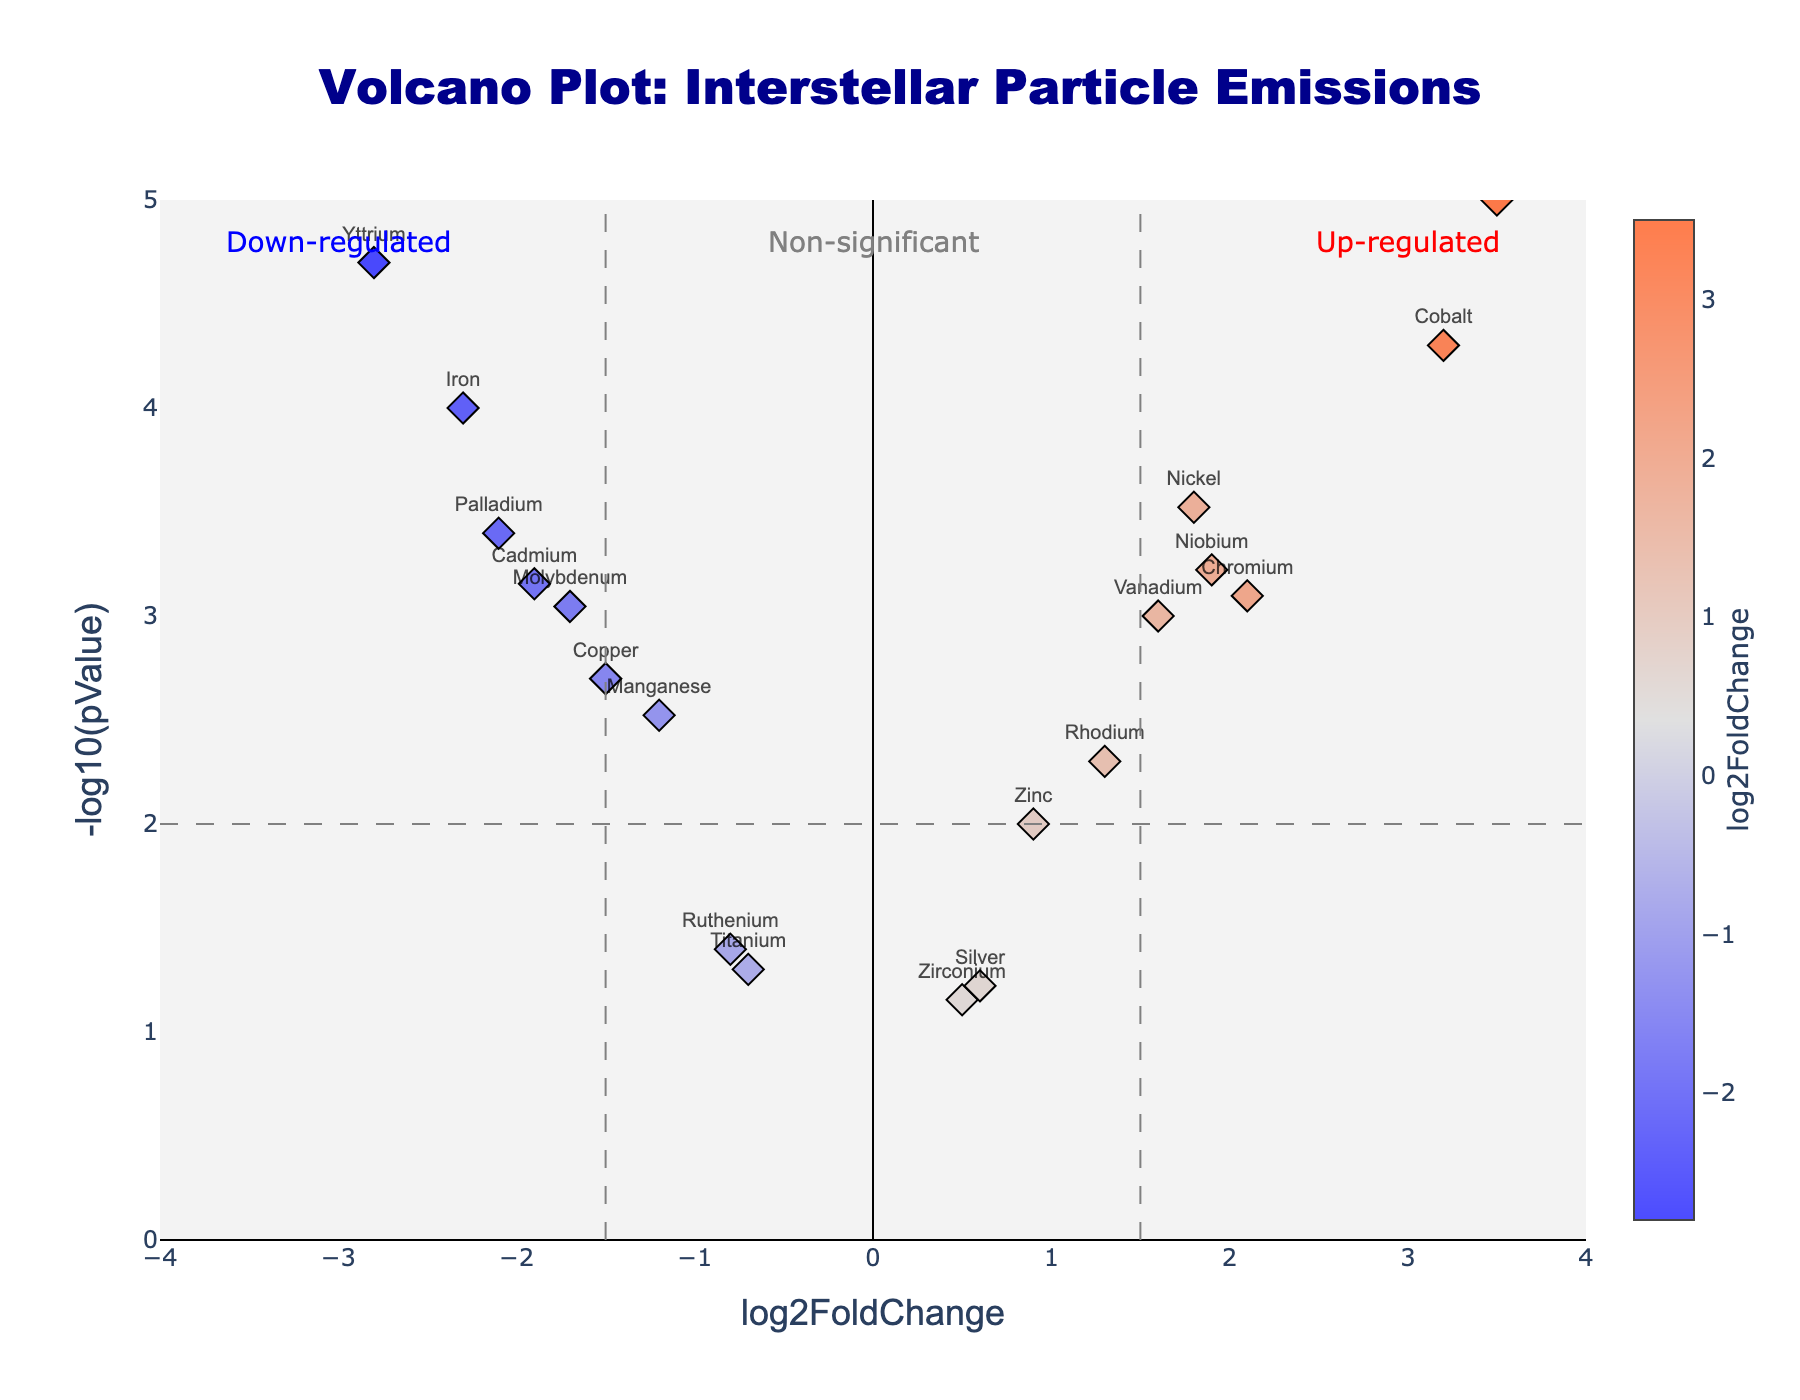Which element shows the highest up-regulation? By examining the y-axis for -log10(pValue) and looking at the highest positive log2FoldChange value, we see Technetium has the highest value.
Answer: Technetium Which element shows the highest down-regulation? By examining the y-axis for -log10(pValue) and looking at the highest negative log2FoldChange value, we see Yttrium has the highest value.
Answer: Yttrium How many elements are significantly up-regulated based on the thresholds? Elements with log2FoldChange > 1.5 and -log10(pValue) > 2 (-log10(pValue) of p < 0.01). We find Nickel, Cobalt, Chromium, Vanadium, Niobium, and Technetium meeting these criteria.
Answer: 6 How many elements are significantly down-regulated based on the thresholds? Elements with log2FoldChange < -1.5 and -log10(pValue) > 2 (-log10(pValue) of p < 0.01). We find Iron, Yttrium, Palladium, and Cadmium meeting these criteria.
Answer: 4 What is the log2FoldChange range? The log2FoldChange axis ranges from approximately -4 to 4.
Answer: -4 to 4 Which elements have a p-value threshold line approximately at -log10(pValue) = 2? Elements with a fold change but not exceeding set thresholds include Zinc, Ruthenium, and Rhodium, near the p-value threshold due to their -log10(pValue) around 2.
Answer: Zinc, Ruthenium, Rhodium Which element has the lowest -log10(pValue) while still being significant? The element just meeting the p-value threshold (slightly above -log10(pValue) = 2) is Titanium.
Answer: Titanium Which element exhibits the highest variance in log2FoldChange among the presented significant ones? From the plot, Technetium with highest positive log2FoldChange (3.5) and Yttrium with highest negative log2FoldChange (-2.8).
Answer: Technetium (positive) and Yttrium (negative) Is there any non-significant element close to the fold change threshold? Zirconium and Silver have small changes in log2FoldChange and -log10(pValue) just below significance.
Answer: Zirconium, Silver 